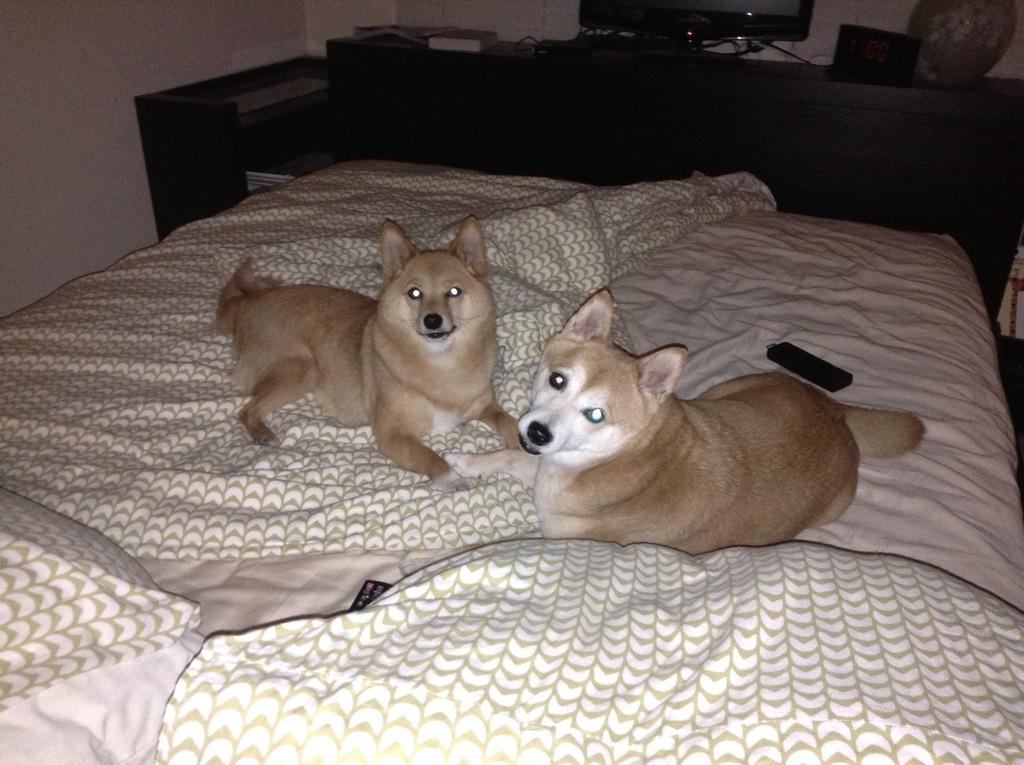How would you summarize this image in a sentence or two? In this image I can see two dogs sitting on the bed. They are in brown and white color. I can see a white color bed sheet and black object on the bed. Back I can see a television,book and some objects on the table. I can see a black color cupboard and wall. 